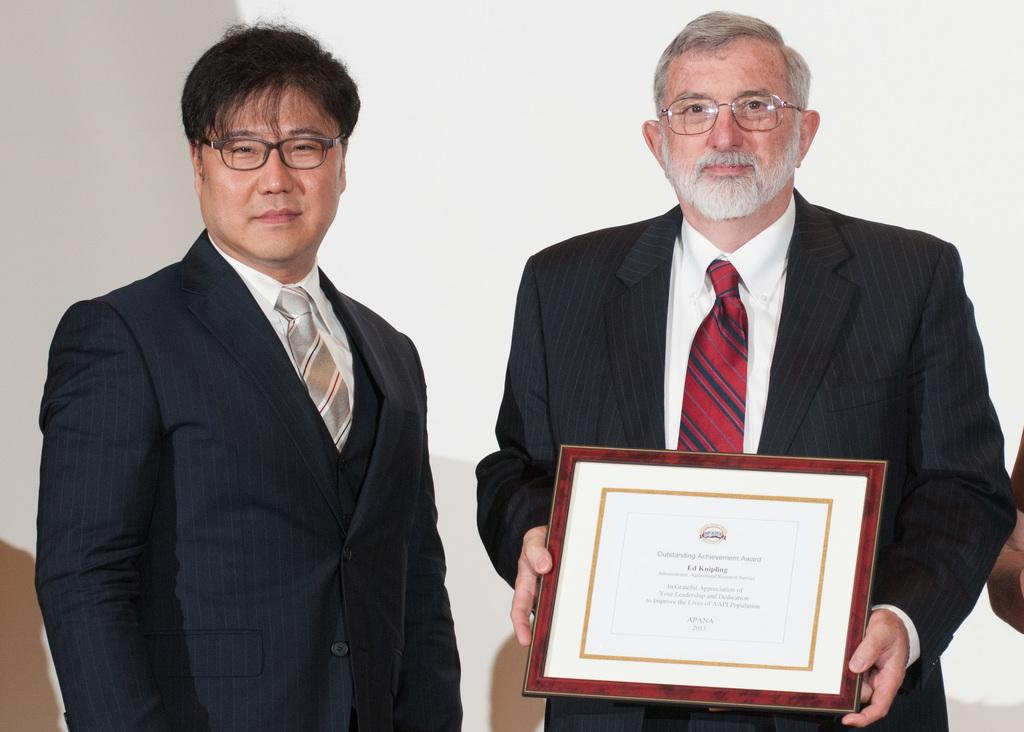How many people are in the image? There are two persons in the image. What is one of the persons holding? One of the persons is holding a shield. What type of rhythm is being played by the person holding the shield in the image? There is no indication of any rhythm being played in the image; the person is simply holding a shield. 